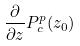<formula> <loc_0><loc_0><loc_500><loc_500>\frac { \partial } { \partial z } P _ { c } ^ { p } ( z _ { 0 } )</formula> 